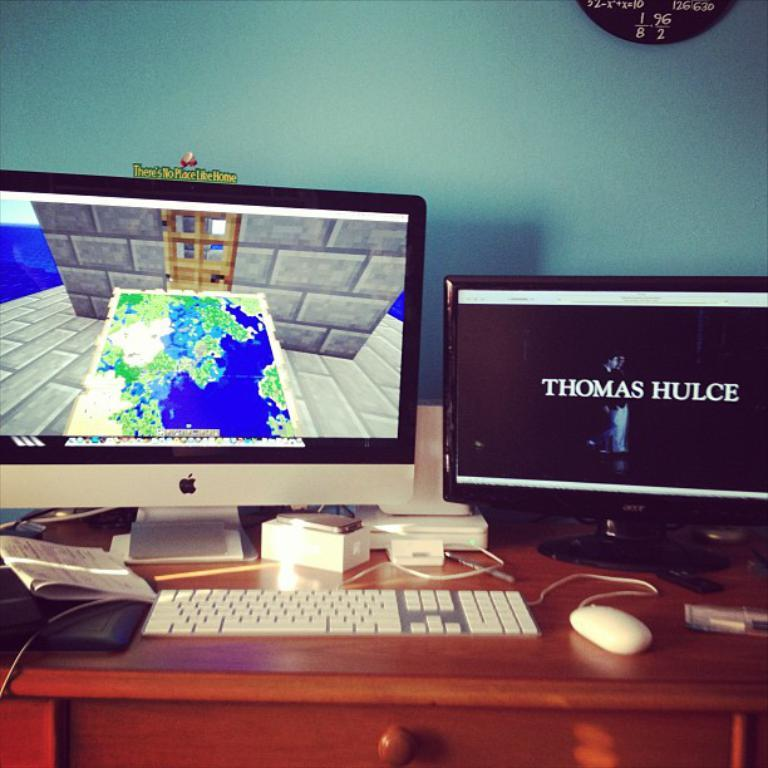What type of computer is visible on the left side of the image? There is a Macbook on the left side of the image. What device is located at the bottom of the image? There is a keyboard at the bottom of the image. What input device is present in the image? There is a mouse in the image. What type of computer is on the right side of the image? There is a desktop on the right side of the image. How many worms can be seen crawling on the keyboard in the image? There are no worms present in the image; it features a keyboard, a Macbook, a mouse, and a desktop. What territory is being claimed by the mouse in the image? There is no indication of territory being claimed in the image; it simply shows a mouse as an input device. 